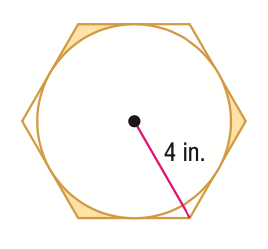Question: Find the area of the shaded region formed by the circle and regular polygon. Round to the nearest tenth.
Choices:
A. 0.6
B. 1.3
C. 1.9
D. 3.9
Answer with the letter. Answer: C 